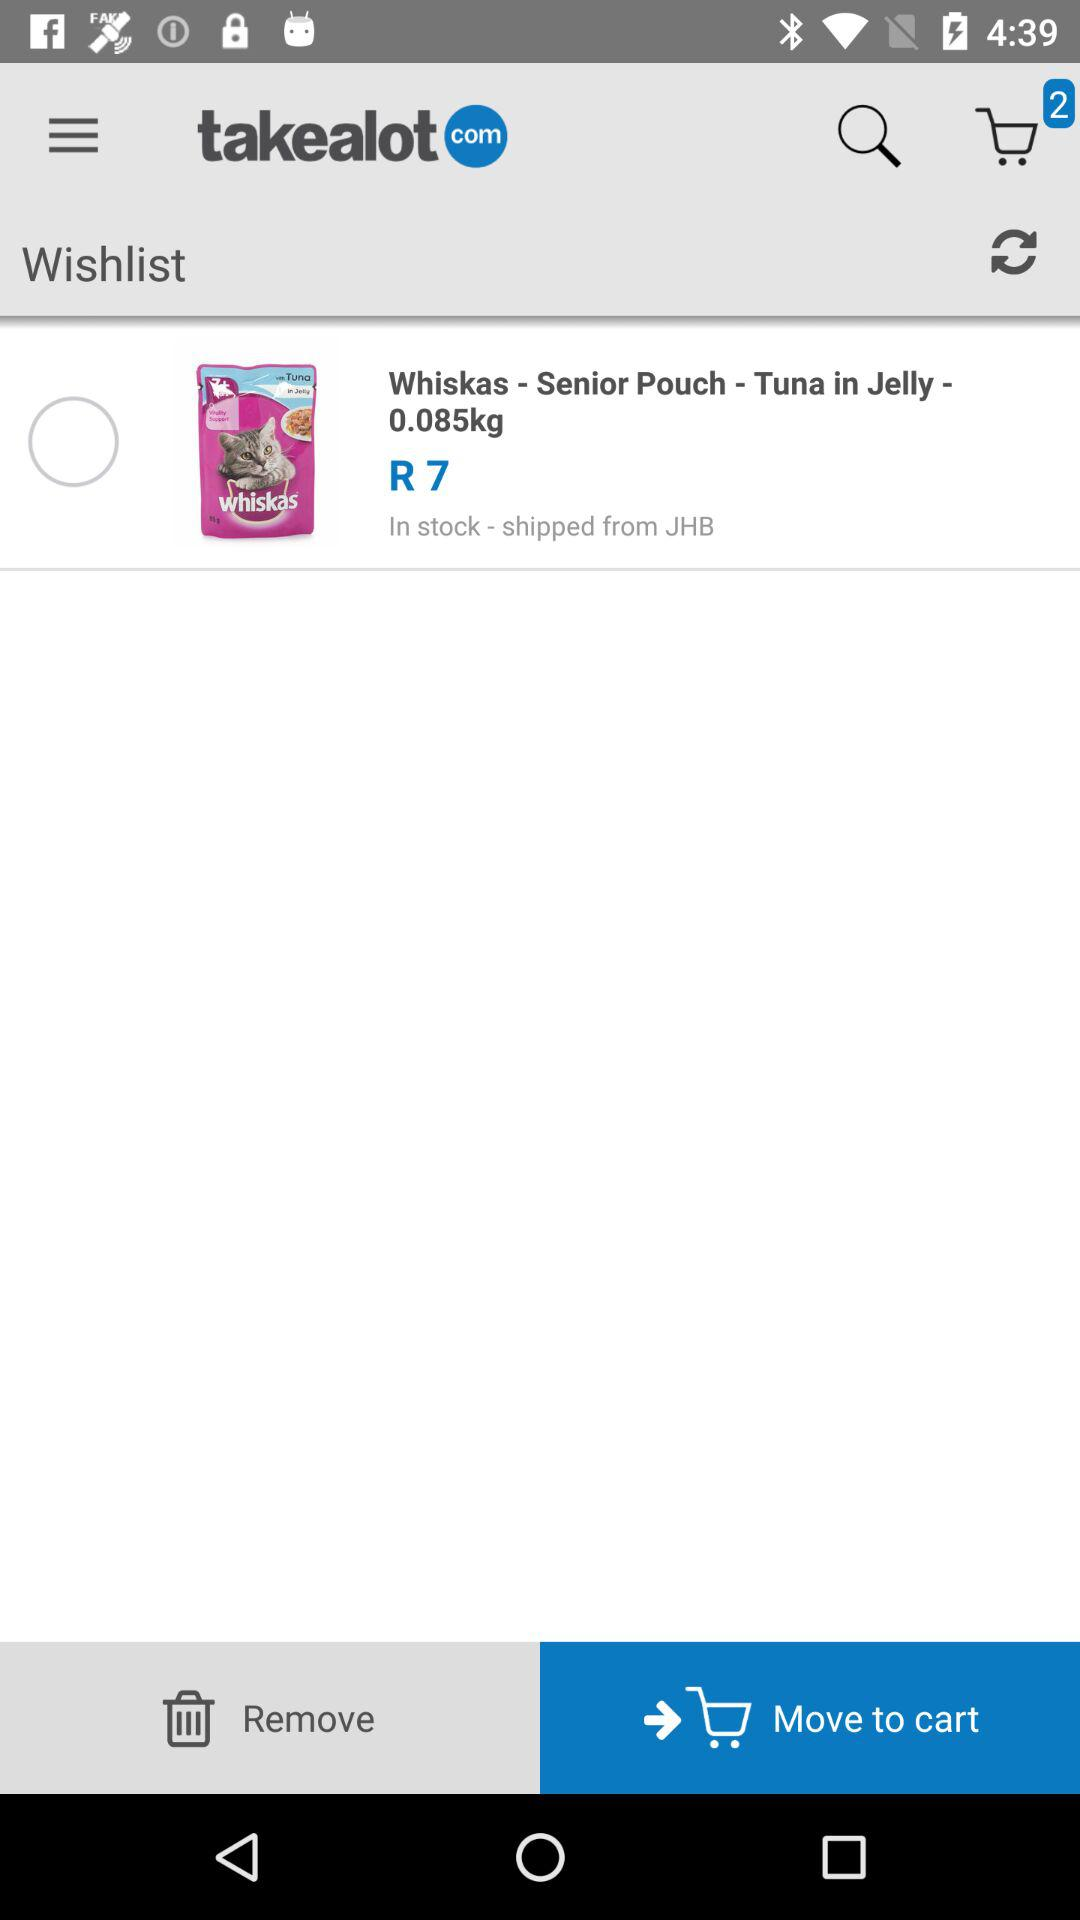What is the count of items in the cart? The count of items is 2. 